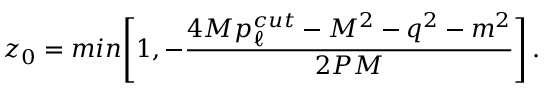Convert formula to latex. <formula><loc_0><loc_0><loc_500><loc_500>z _ { 0 } = \min \left [ 1 , - { \frac { 4 M p _ { \ell } ^ { c u t } - M ^ { 2 } - q ^ { 2 } - m ^ { 2 } } { 2 P M } } \right ] \, .</formula> 